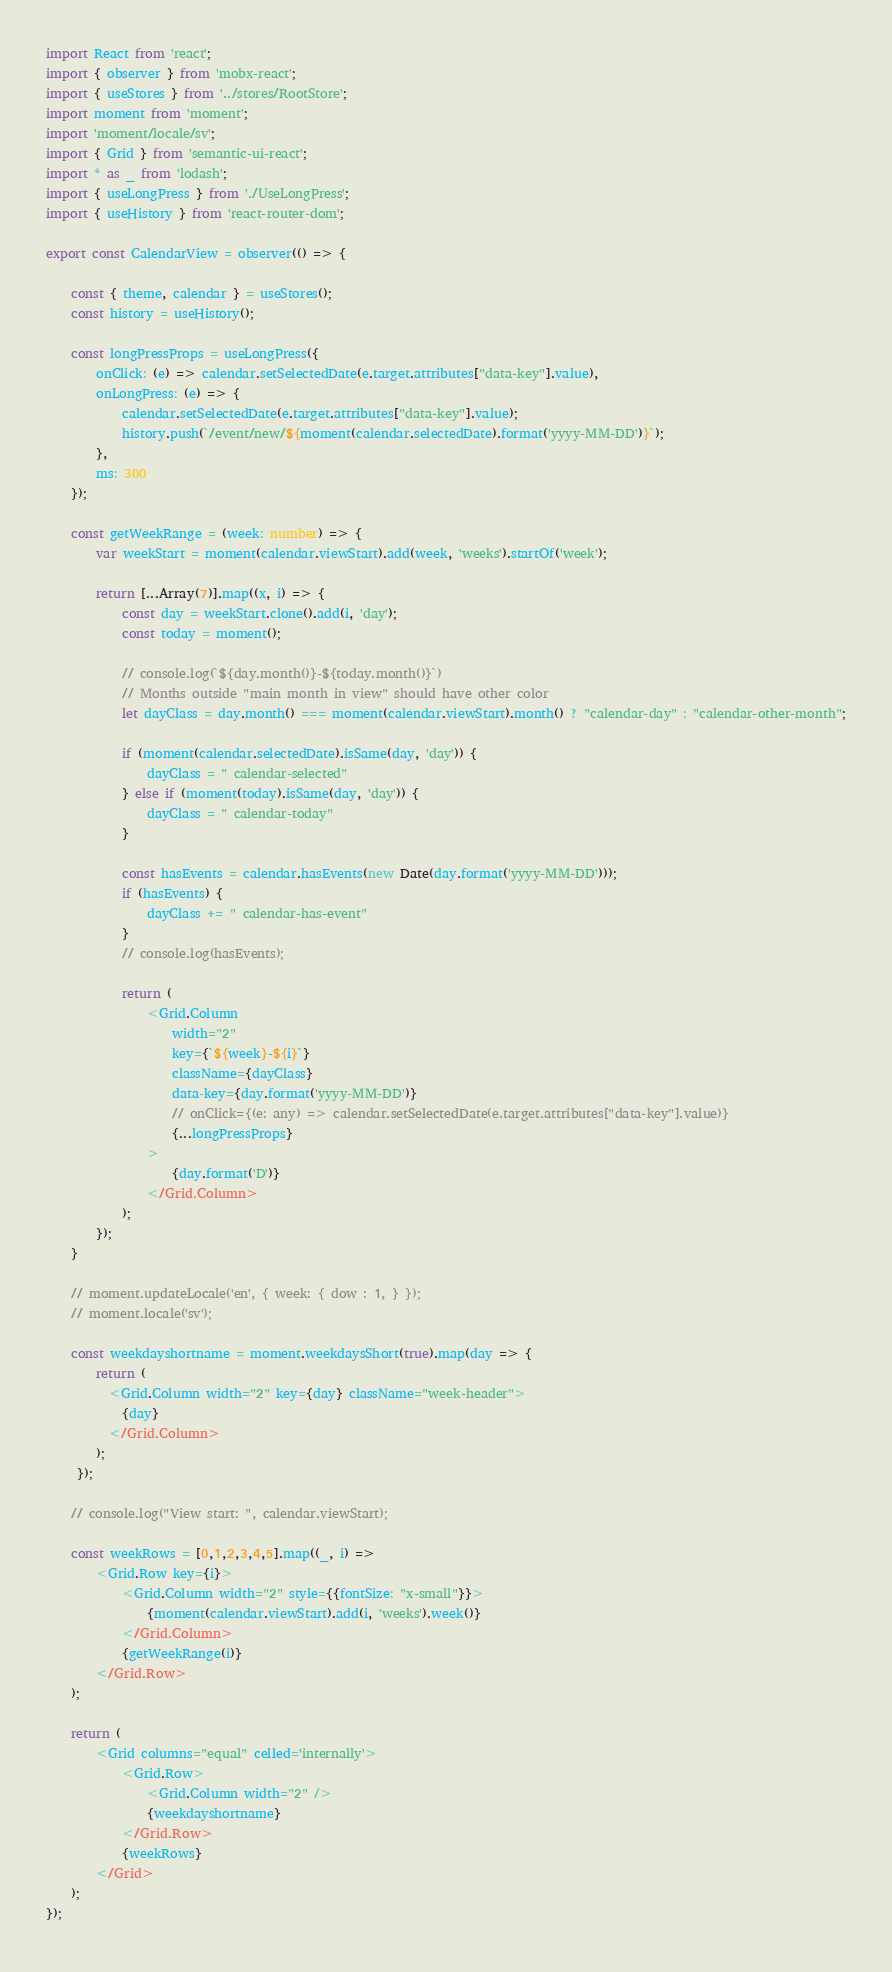<code> <loc_0><loc_0><loc_500><loc_500><_TypeScript_>import React from 'react';
import { observer } from 'mobx-react';
import { useStores } from '../stores/RootStore';
import moment from 'moment';
import 'moment/locale/sv';
import { Grid } from 'semantic-ui-react';
import * as _ from 'lodash';
import { useLongPress } from './UseLongPress';
import { useHistory } from 'react-router-dom';

export const CalendarView = observer(() => {

    const { theme, calendar } = useStores();
    const history = useHistory();

    const longPressProps = useLongPress({
        onClick: (e) => calendar.setSelectedDate(e.target.attributes["data-key"].value),
        onLongPress: (e) => {
            calendar.setSelectedDate(e.target.attributes["data-key"].value);
            history.push(`/event/new/${moment(calendar.selectedDate).format('yyyy-MM-DD')}`);
        },
        ms: 300
    });

    const getWeekRange = (week: number) => {
        var weekStart = moment(calendar.viewStart).add(week, 'weeks').startOf('week');

        return [...Array(7)].map((x, i) => {
            const day = weekStart.clone().add(i, 'day');
            const today = moment();
            
            // console.log(`${day.month()}-${today.month()}`)
            // Months outside "main month in view" should have other color
            let dayClass = day.month() === moment(calendar.viewStart).month() ? "calendar-day" : "calendar-other-month";

            if (moment(calendar.selectedDate).isSame(day, 'day')) {
                dayClass = " calendar-selected"
            } else if (moment(today).isSame(day, 'day')) {
                dayClass = " calendar-today"
            }

            const hasEvents = calendar.hasEvents(new Date(day.format('yyyy-MM-DD')));
            if (hasEvents) {
                dayClass += " calendar-has-event"
            }
            // console.log(hasEvents);

            return (
                <Grid.Column 
                    width="2" 
                    key={`${week}-${i}`} 
                    className={dayClass} 
                    data-key={day.format('yyyy-MM-DD')}
                    // onClick={(e: any) => calendar.setSelectedDate(e.target.attributes["data-key"].value)}
                    {...longPressProps}
                >
                    {day.format('D')}
                </Grid.Column>
            );
        });
    }

    // moment.updateLocale('en', { week: { dow : 1, } });
    // moment.locale('sv');

    const weekdayshortname = moment.weekdaysShort(true).map(day => {
        return (
          <Grid.Column width="2" key={day} className="week-header">
            {day}
          </Grid.Column>
        );
     });

    // console.log("View start: ", calendar.viewStart);

    const weekRows = [0,1,2,3,4,5].map((_, i) => 
        <Grid.Row key={i}>
            <Grid.Column width="2" style={{fontSize: "x-small"}}>
                {moment(calendar.viewStart).add(i, 'weeks').week()}
            </Grid.Column>
            {getWeekRange(i)}
        </Grid.Row>
    );

    return (
        <Grid columns="equal" celled='internally'>
            <Grid.Row>
                <Grid.Column width="2" />
                {weekdayshortname}
            </Grid.Row>
            {weekRows}
        </Grid>
    );
});</code> 